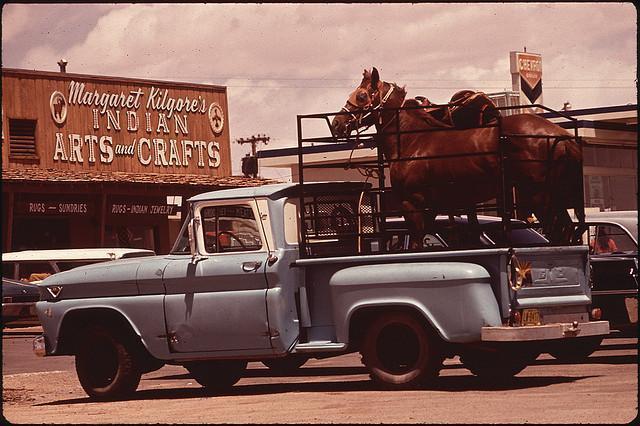How many horses are there?
Give a very brief answer. 1. How many zebras are there?
Give a very brief answer. 0. 